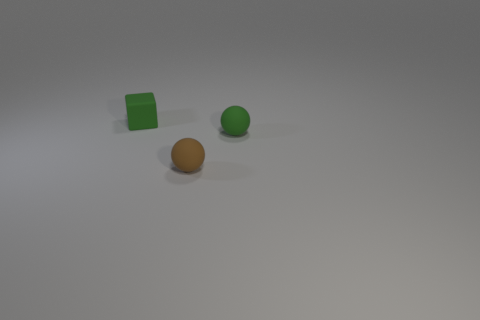What materials might these objects be made of? The objects have a smooth and relatively uniform texture suggestive of being made from synthetic materials, possibly plastic or a composite. 